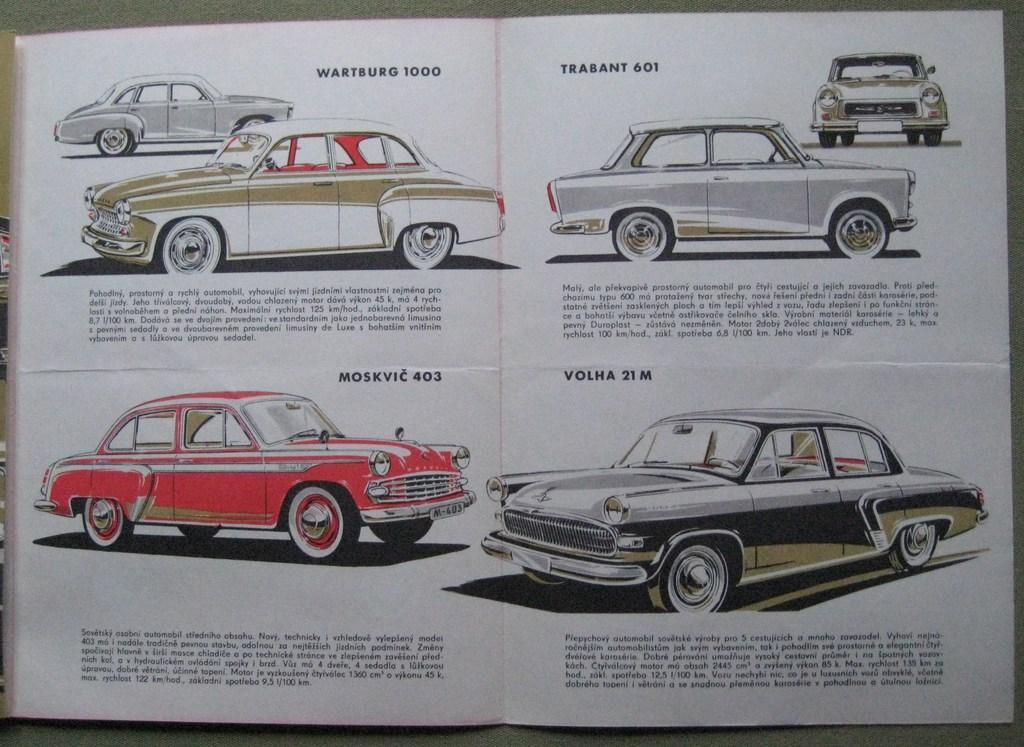What is the main subject in the center of the image? There is a paper in the center of the image. What else can be seen in the image besides the paper? There are vehicles visible in the image. Is there any text present in the image? Yes, there is text present in the image. What month is depicted in the image? There is no month depicted in the image; it features a paper, vehicles, and text. How many trains are visible in the image? There are no trains visible in the image; it features a paper, vehicles, and text. 